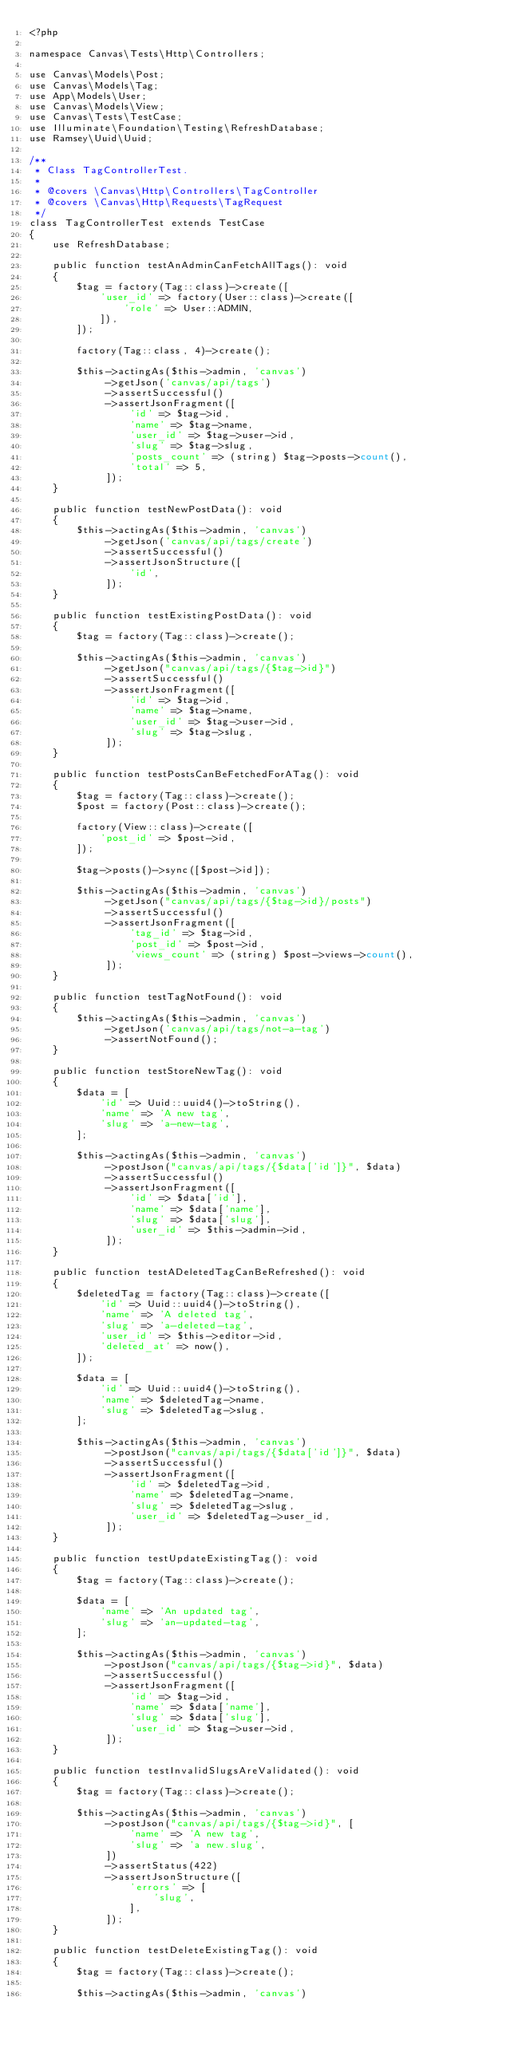<code> <loc_0><loc_0><loc_500><loc_500><_PHP_><?php

namespace Canvas\Tests\Http\Controllers;

use Canvas\Models\Post;
use Canvas\Models\Tag;
use App\Models\User;
use Canvas\Models\View;
use Canvas\Tests\TestCase;
use Illuminate\Foundation\Testing\RefreshDatabase;
use Ramsey\Uuid\Uuid;

/**
 * Class TagControllerTest.
 *
 * @covers \Canvas\Http\Controllers\TagController
 * @covers \Canvas\Http\Requests\TagRequest
 */
class TagControllerTest extends TestCase
{
    use RefreshDatabase;

    public function testAnAdminCanFetchAllTags(): void
    {
        $tag = factory(Tag::class)->create([
            'user_id' => factory(User::class)->create([
                'role' => User::ADMIN,
            ]),
        ]);

        factory(Tag::class, 4)->create();

        $this->actingAs($this->admin, 'canvas')
             ->getJson('canvas/api/tags')
             ->assertSuccessful()
             ->assertJsonFragment([
                 'id' => $tag->id,
                 'name' => $tag->name,
                 'user_id' => $tag->user->id,
                 'slug' => $tag->slug,
                 'posts_count' => (string) $tag->posts->count(),
                 'total' => 5,
             ]);
    }

    public function testNewPostData(): void
    {
        $this->actingAs($this->admin, 'canvas')
             ->getJson('canvas/api/tags/create')
             ->assertSuccessful()
             ->assertJsonStructure([
                 'id',
             ]);
    }

    public function testExistingPostData(): void
    {
        $tag = factory(Tag::class)->create();

        $this->actingAs($this->admin, 'canvas')
             ->getJson("canvas/api/tags/{$tag->id}")
             ->assertSuccessful()
             ->assertJsonFragment([
                 'id' => $tag->id,
                 'name' => $tag->name,
                 'user_id' => $tag->user->id,
                 'slug' => $tag->slug,
             ]);
    }

    public function testPostsCanBeFetchedForATag(): void
    {
        $tag = factory(Tag::class)->create();
        $post = factory(Post::class)->create();

        factory(View::class)->create([
            'post_id' => $post->id,
        ]);

        $tag->posts()->sync([$post->id]);

        $this->actingAs($this->admin, 'canvas')
             ->getJson("canvas/api/tags/{$tag->id}/posts")
             ->assertSuccessful()
             ->assertJsonFragment([
                 'tag_id' => $tag->id,
                 'post_id' => $post->id,
                 'views_count' => (string) $post->views->count(),
             ]);
    }

    public function testTagNotFound(): void
    {
        $this->actingAs($this->admin, 'canvas')
             ->getJson('canvas/api/tags/not-a-tag')
             ->assertNotFound();
    }

    public function testStoreNewTag(): void
    {
        $data = [
            'id' => Uuid::uuid4()->toString(),
            'name' => 'A new tag',
            'slug' => 'a-new-tag',
        ];

        $this->actingAs($this->admin, 'canvas')
             ->postJson("canvas/api/tags/{$data['id']}", $data)
             ->assertSuccessful()
             ->assertJsonFragment([
                 'id' => $data['id'],
                 'name' => $data['name'],
                 'slug' => $data['slug'],
                 'user_id' => $this->admin->id,
             ]);
    }

    public function testADeletedTagCanBeRefreshed(): void
    {
        $deletedTag = factory(Tag::class)->create([
            'id' => Uuid::uuid4()->toString(),
            'name' => 'A deleted tag',
            'slug' => 'a-deleted-tag',
            'user_id' => $this->editor->id,
            'deleted_at' => now(),
        ]);

        $data = [
            'id' => Uuid::uuid4()->toString(),
            'name' => $deletedTag->name,
            'slug' => $deletedTag->slug,
        ];

        $this->actingAs($this->admin, 'canvas')
             ->postJson("canvas/api/tags/{$data['id']}", $data)
             ->assertSuccessful()
             ->assertJsonFragment([
                 'id' => $deletedTag->id,
                 'name' => $deletedTag->name,
                 'slug' => $deletedTag->slug,
                 'user_id' => $deletedTag->user_id,
             ]);
    }

    public function testUpdateExistingTag(): void
    {
        $tag = factory(Tag::class)->create();

        $data = [
            'name' => 'An updated tag',
            'slug' => 'an-updated-tag',
        ];

        $this->actingAs($this->admin, 'canvas')
             ->postJson("canvas/api/tags/{$tag->id}", $data)
             ->assertSuccessful()
             ->assertJsonFragment([
                 'id' => $tag->id,
                 'name' => $data['name'],
                 'slug' => $data['slug'],
                 'user_id' => $tag->user->id,
             ]);
    }

    public function testInvalidSlugsAreValidated(): void
    {
        $tag = factory(Tag::class)->create();

        $this->actingAs($this->admin, 'canvas')
             ->postJson("canvas/api/tags/{$tag->id}", [
                 'name' => 'A new tag',
                 'slug' => 'a new.slug',
             ])
             ->assertStatus(422)
             ->assertJsonStructure([
                 'errors' => [
                     'slug',
                 ],
             ]);
    }

    public function testDeleteExistingTag(): void
    {
        $tag = factory(Tag::class)->create();

        $this->actingAs($this->admin, 'canvas')</code> 